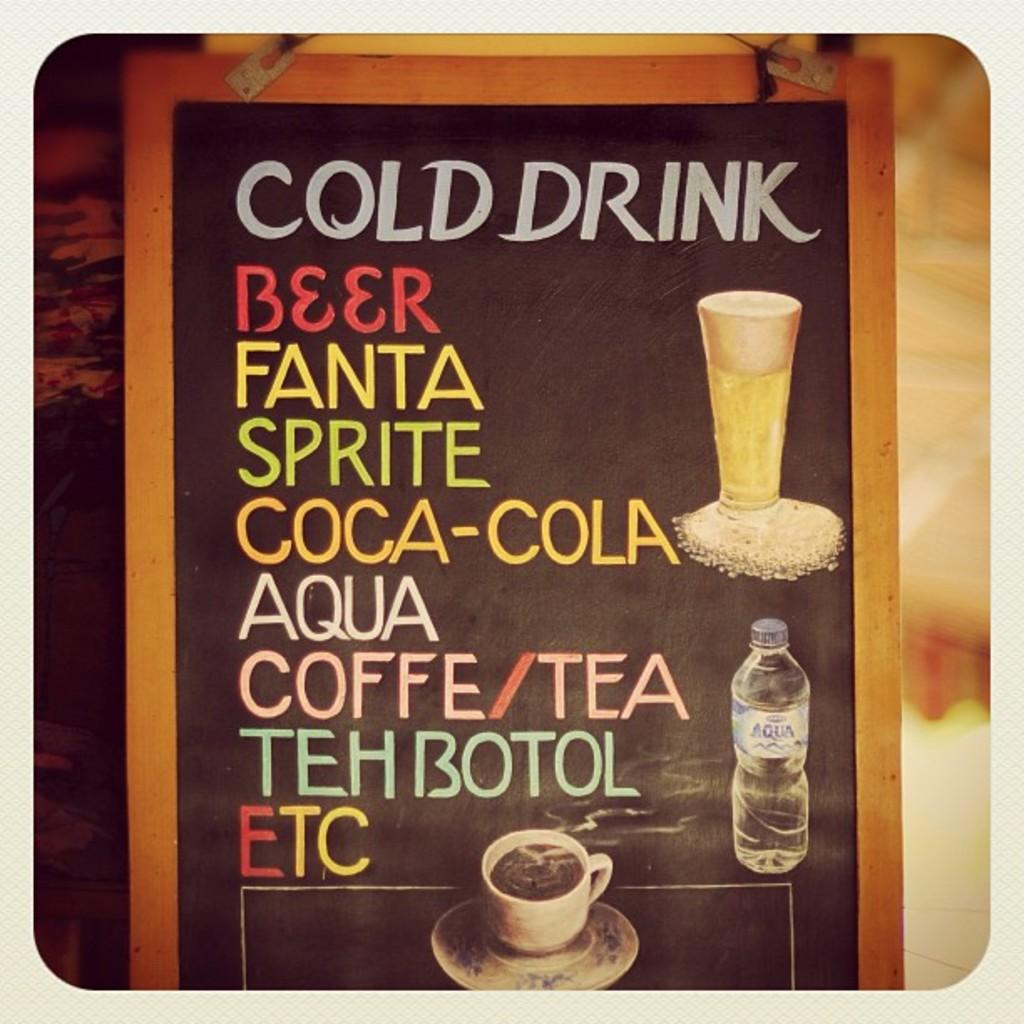<image>
Render a clear and concise summary of the photo. A board that is advertising various cold drinks also shows that coffee and tea are available. 